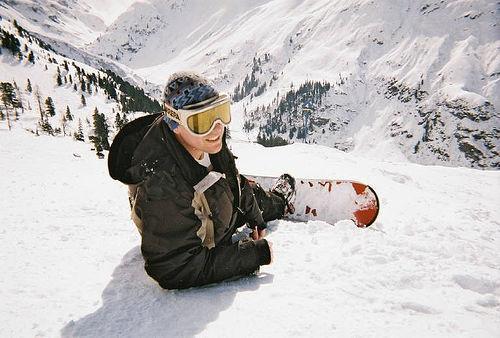How many people are there?
Give a very brief answer. 1. How many people in the image are eating apples?
Give a very brief answer. 0. How many red snowboards are in the image?
Give a very brief answer. 1. 